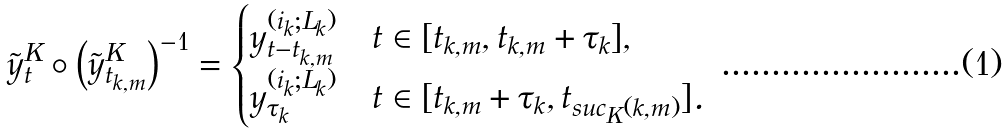Convert formula to latex. <formula><loc_0><loc_0><loc_500><loc_500>\tilde { y } _ { t } ^ { K } \circ \left ( \tilde { y } _ { t _ { k , m } } ^ { K } \right ) ^ { - 1 } = \begin{cases} y _ { t - t _ { k , m } } ^ { ( i _ { k } ; L _ { k } ) } & t \in [ t _ { k , m } , t _ { k , m } + \tau _ { k } ] , \\ y _ { \tau _ { k } } ^ { ( i _ { k } ; L _ { k } ) } & t \in [ t _ { k , m } + \tau _ { k } , t _ { s u c _ { K } ( k , m ) } ] . \end{cases}</formula> 